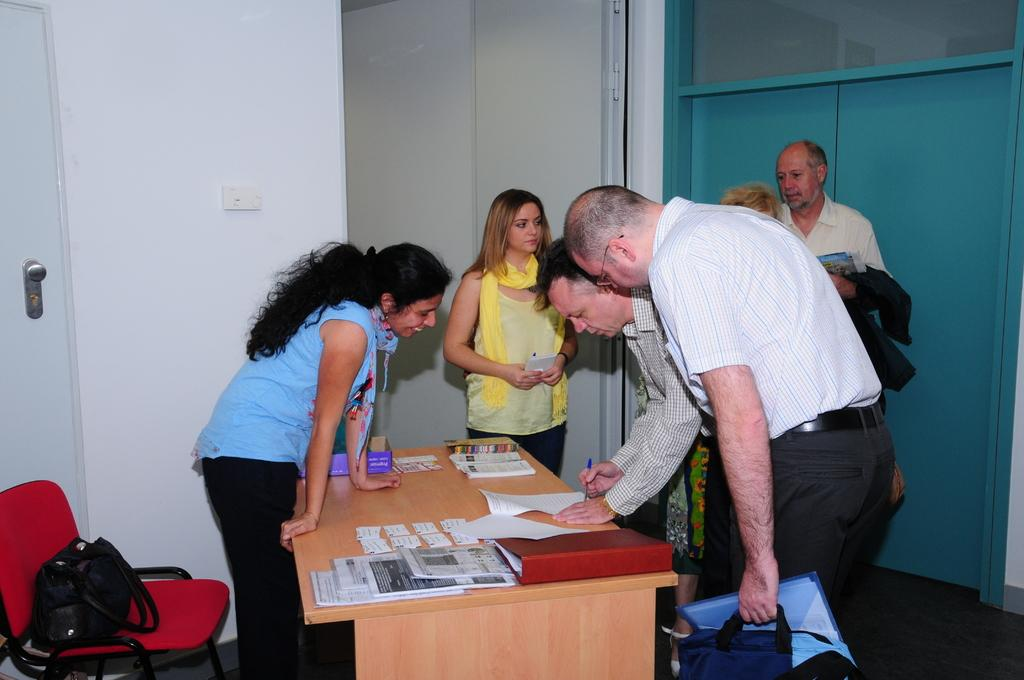How many people are in the image? There is a group of people in the image. What are the people doing in the image? The people are standing around a table. What items can be seen on the table? There are papers, files, and a handbag on the table. Is there any seating near the table? Yes, there is a chair near the table. What type of disgust can be seen on the ladybug's face in the image? There is no ladybug present in the image, so it is not possible to determine any emotions or expressions on its face. 